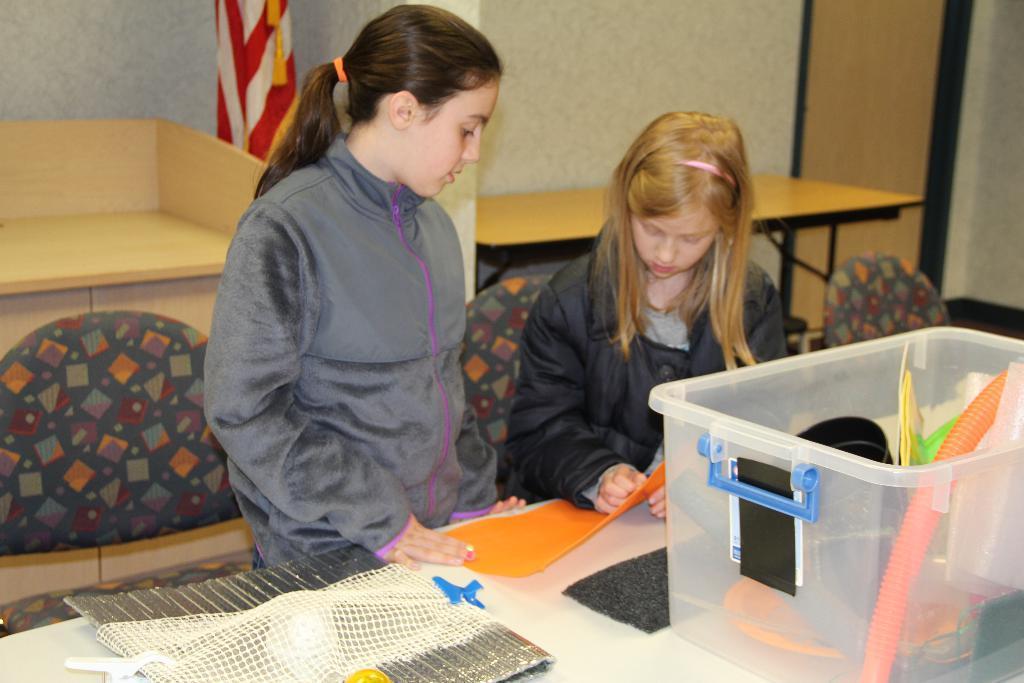In one or two sentences, can you explain what this image depicts? There are two girls here in the given picture. Both of them are standing in front of a table on which some accessories were placed along with the basket here. In the background there are some chairs and a cloth here. We can observe a wall here and a table. 